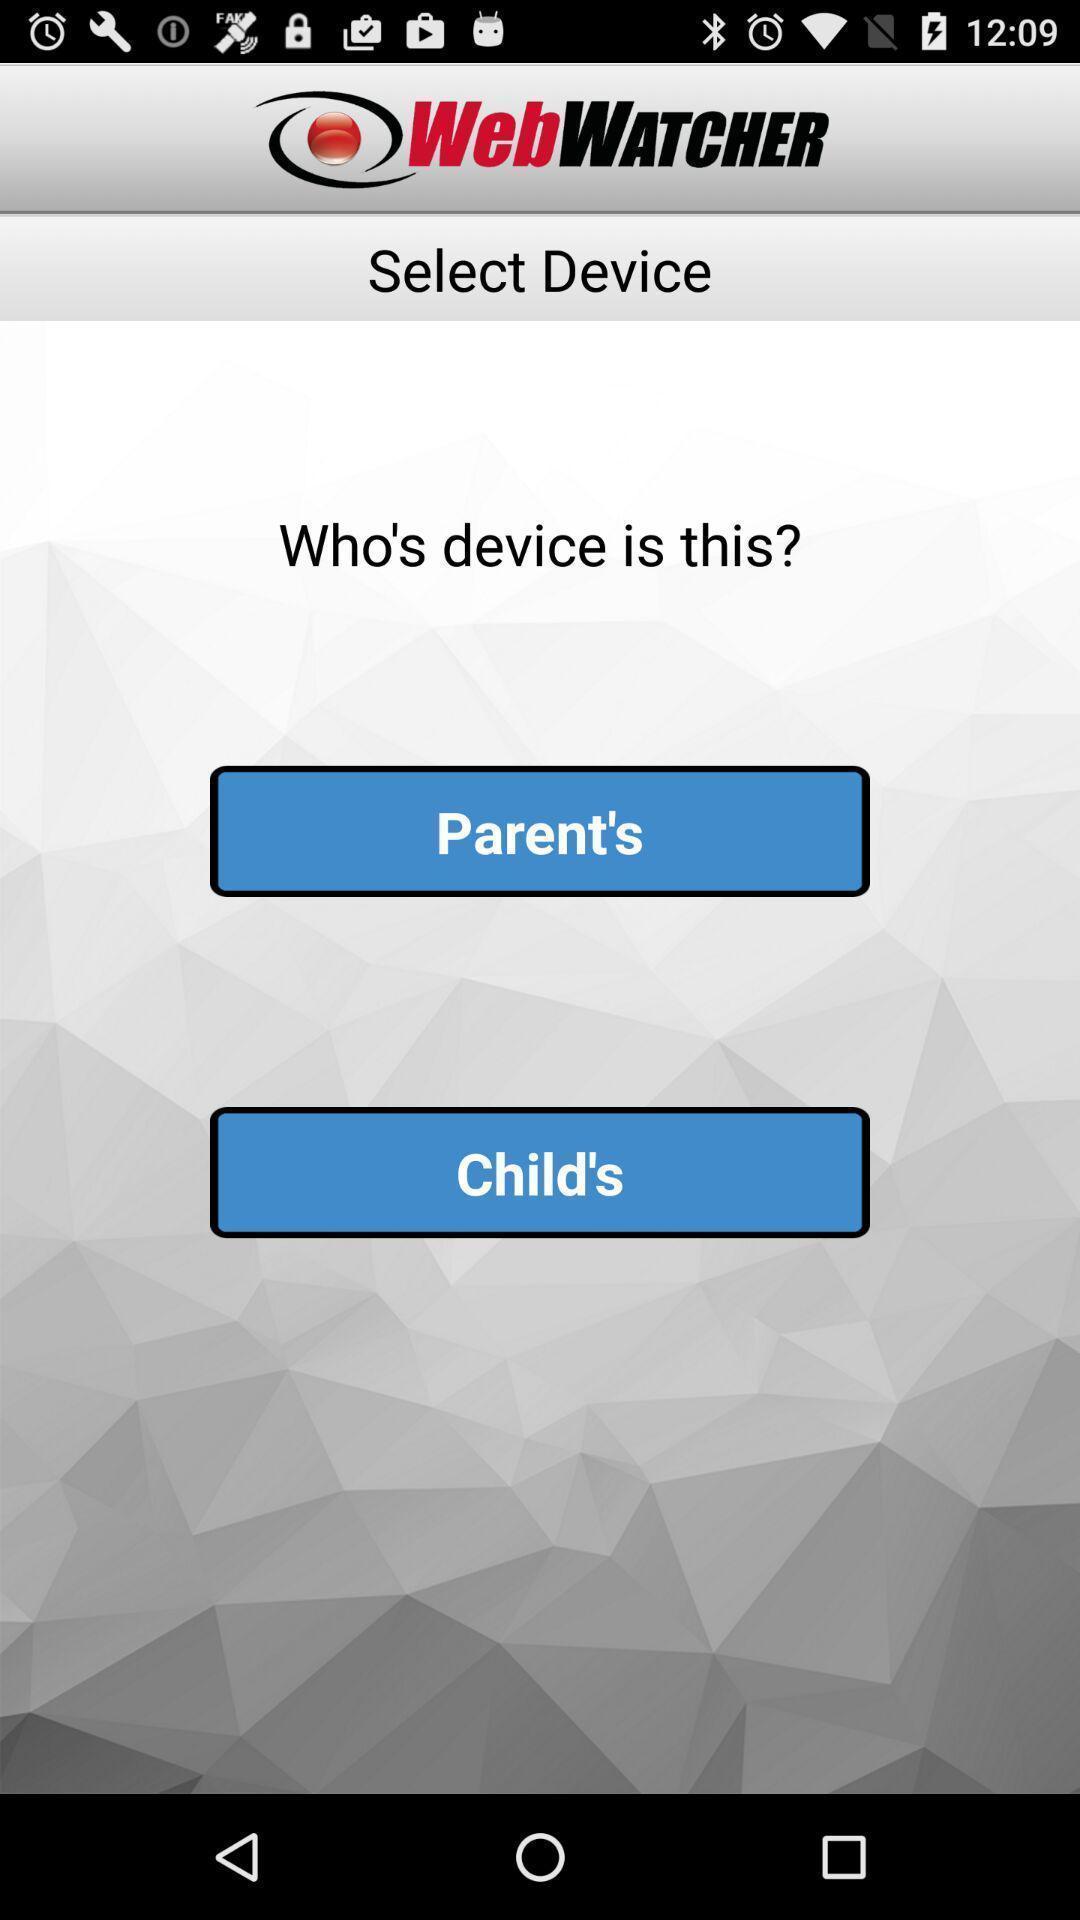Describe the visual elements of this screenshot. Select device page of an online tracking app. 